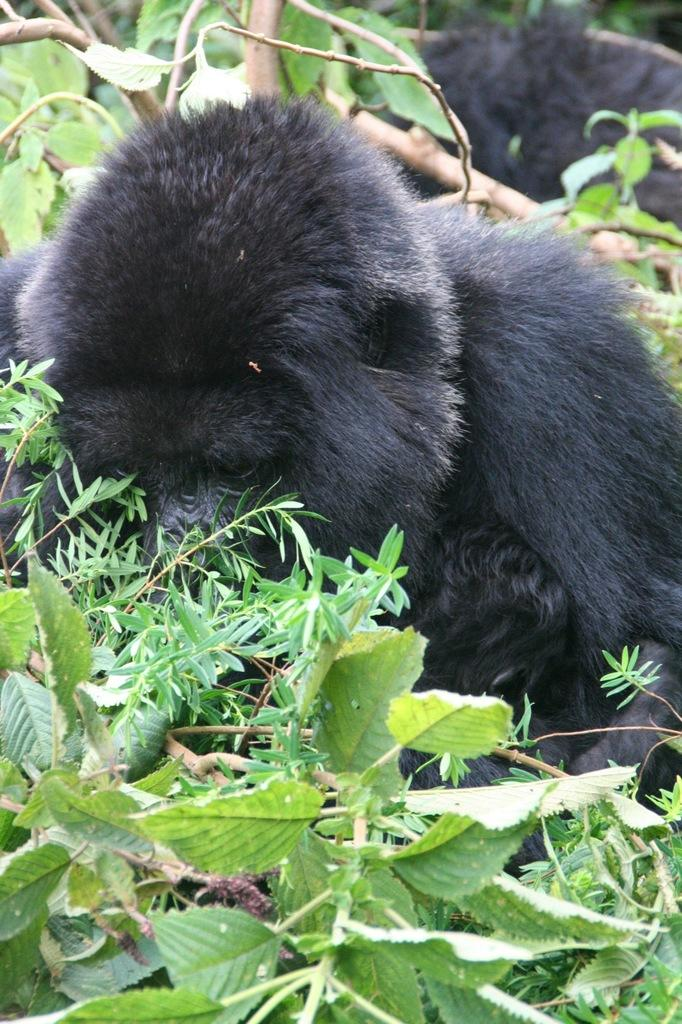What type of animal is in the image? There is a gorilla in the image. What else can be seen in the image besides the gorilla? There are leaves in the image. What type of calendar is hanging on the wall in the image? There is no wall or calendar present in the image; it only features a gorilla and leaves. 